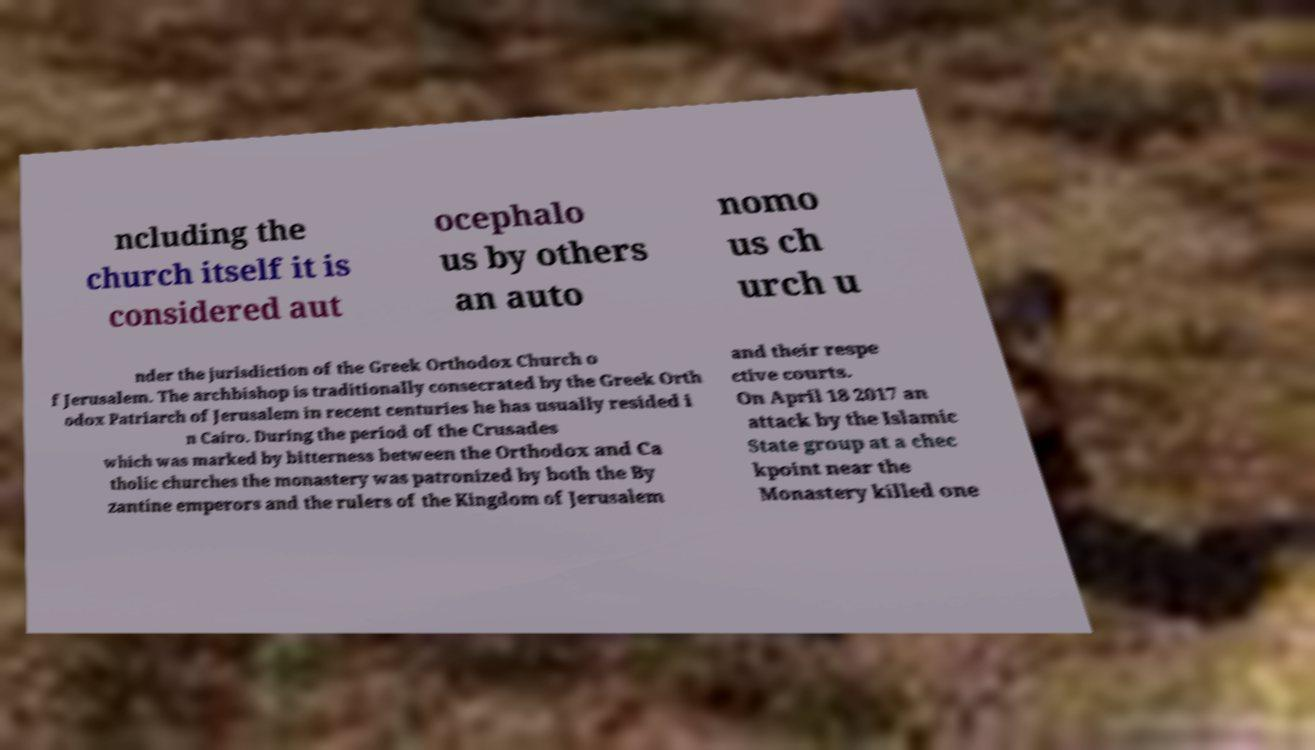There's text embedded in this image that I need extracted. Can you transcribe it verbatim? ncluding the church itself it is considered aut ocephalo us by others an auto nomo us ch urch u nder the jurisdiction of the Greek Orthodox Church o f Jerusalem. The archbishop is traditionally consecrated by the Greek Orth odox Patriarch of Jerusalem in recent centuries he has usually resided i n Cairo. During the period of the Crusades which was marked by bitterness between the Orthodox and Ca tholic churches the monastery was patronized by both the By zantine emperors and the rulers of the Kingdom of Jerusalem and their respe ctive courts. On April 18 2017 an attack by the Islamic State group at a chec kpoint near the Monastery killed one 